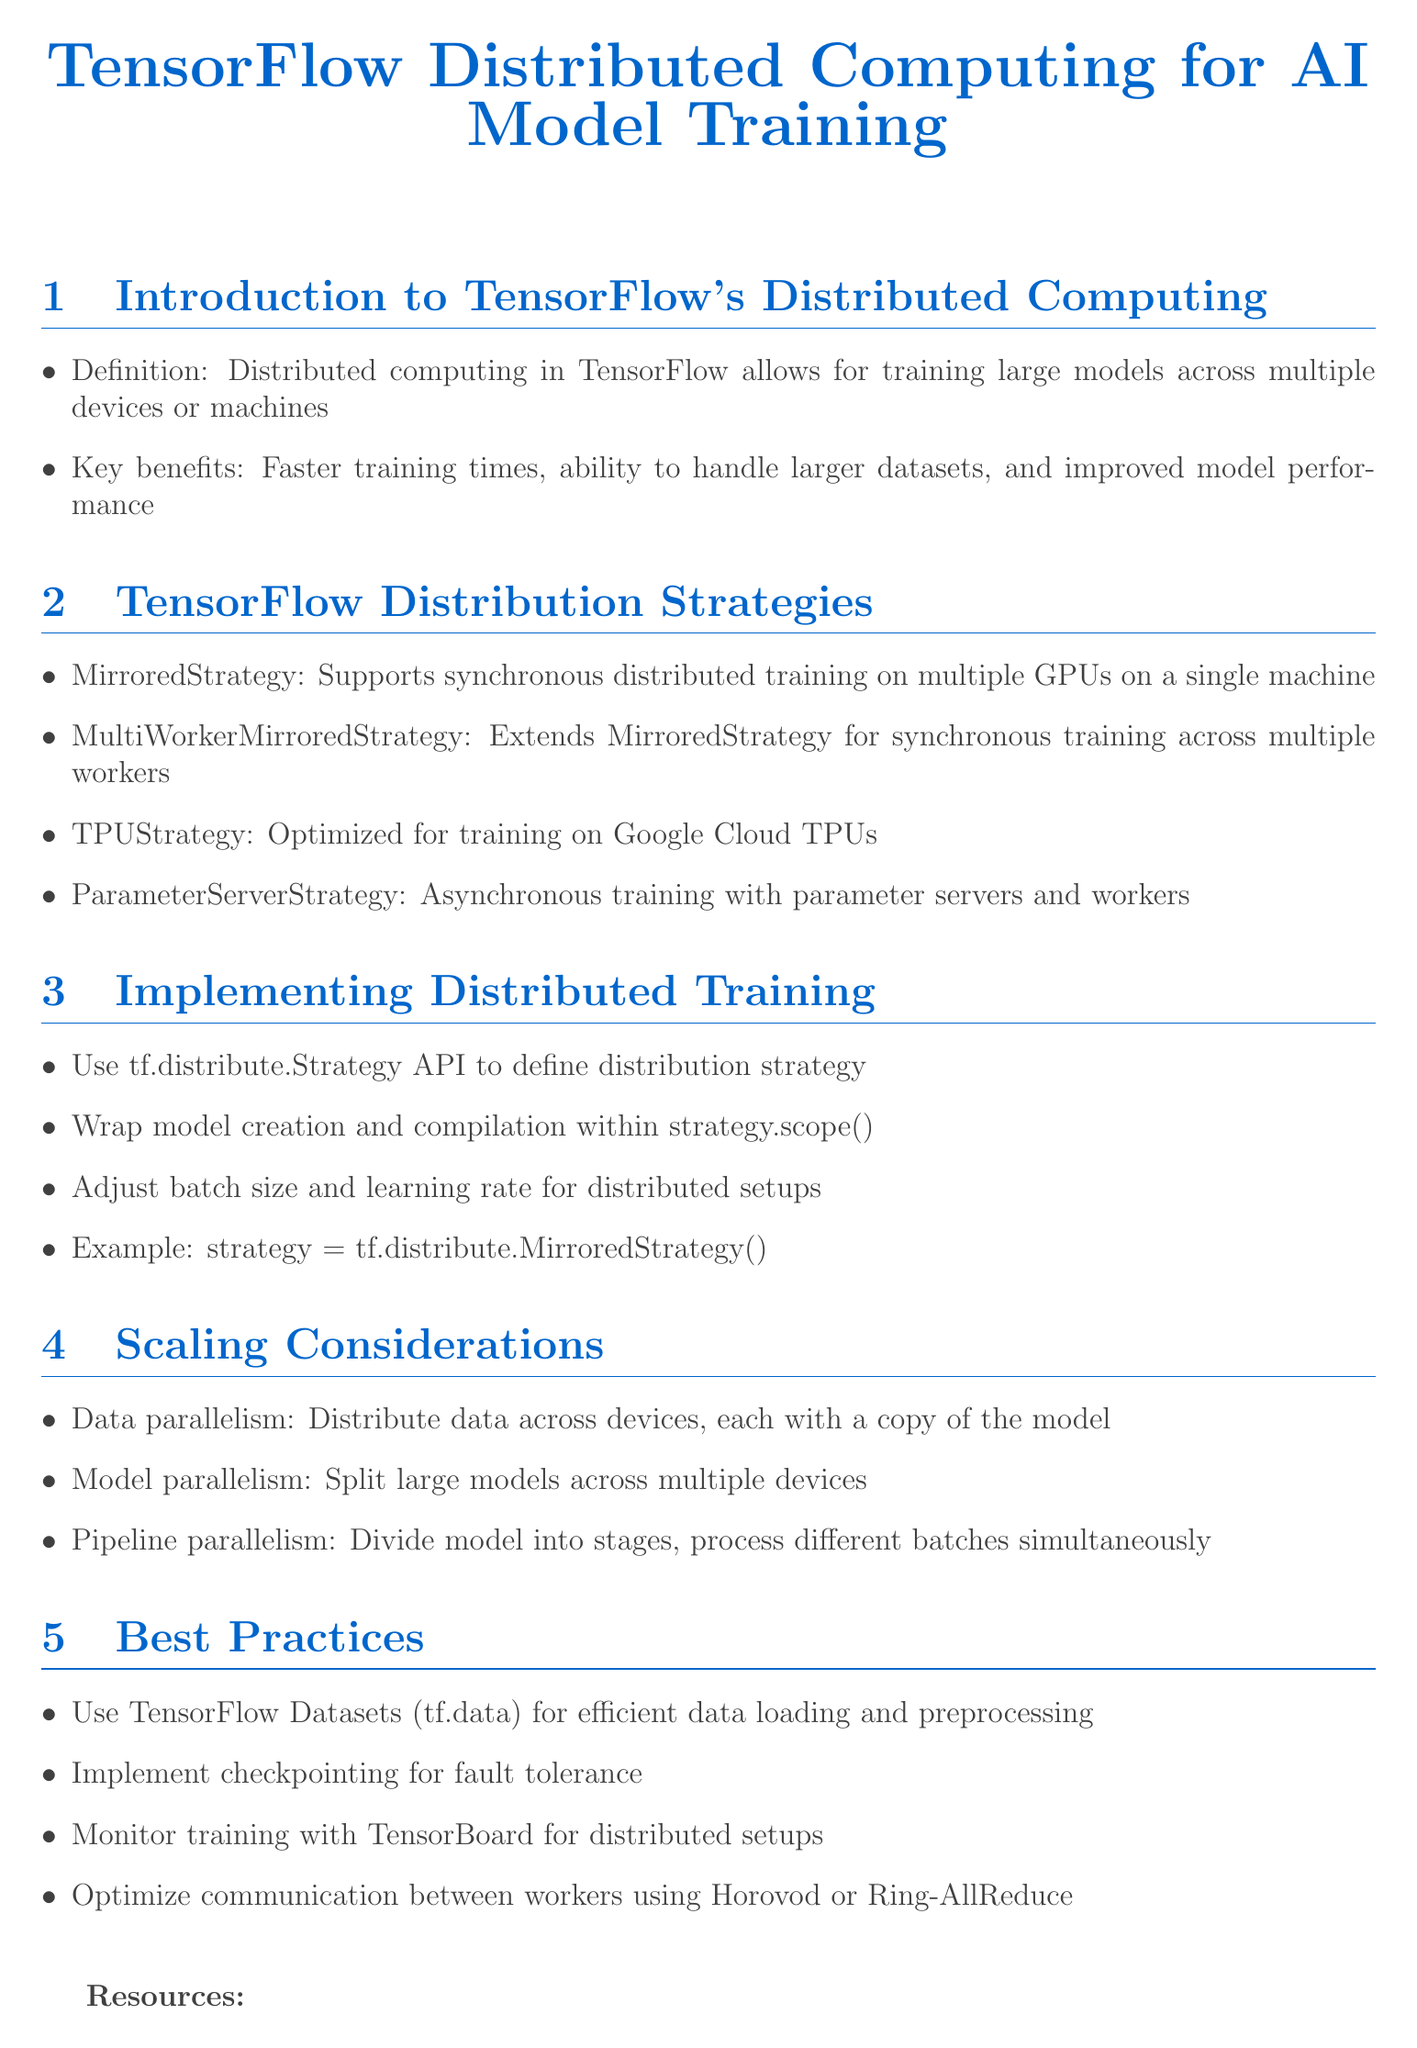What is the title of the document? The title of the document is prominently displayed at the top, stating the focus on TensorFlow and distributed computing for AI model training.
Answer: TensorFlow Distributed Computing for AI Model Training What is MirroredStrategy used for? MirroredStrategy is specifically mentioned as a method that supports synchronous distributed training on multiple GPUs on a single machine.
Answer: Synchronous distributed training on multiple GPUs on a single machine What are the key benefits of distributed computing? The document lists several advantages, including faster training times, larger dataset handling, and improved model performance.
Answer: Faster training times, ability to handle larger datasets, improved model performance What does tf.distribute.Strategy API do? The document explains that this API is used to define a distribution strategy for implementing distributed training.
Answer: Define distribution strategy Which strategy is optimized for training on Google Cloud TPUs? The section on distribution strategies identifies a specific strategy that is tailored for TPUs.
Answer: TPUStrategy What is one best practice for efficient data loading? One best practice highlighted for efficient data handling during training is the use of a specific dataset tool provided by TensorFlow.
Answer: TensorFlow Datasets (tf.data) What type of parallelism involves distributing data across devices? The document includes specific types of parallelism and describes one that relates to how data is managed across devices.
Answer: Data parallelism How can training be monitored in distributed setups? The document suggests using a specific TensorFlow tool for monitoring training processes within distributed environments.
Answer: TensorBoard What is an example of a distributed training strategy? An example provided in the document for a distribution strategy is straightforwardly mentioned in the implementation section.
Answer: strategy = tf.distribute.MirroredStrategy() 